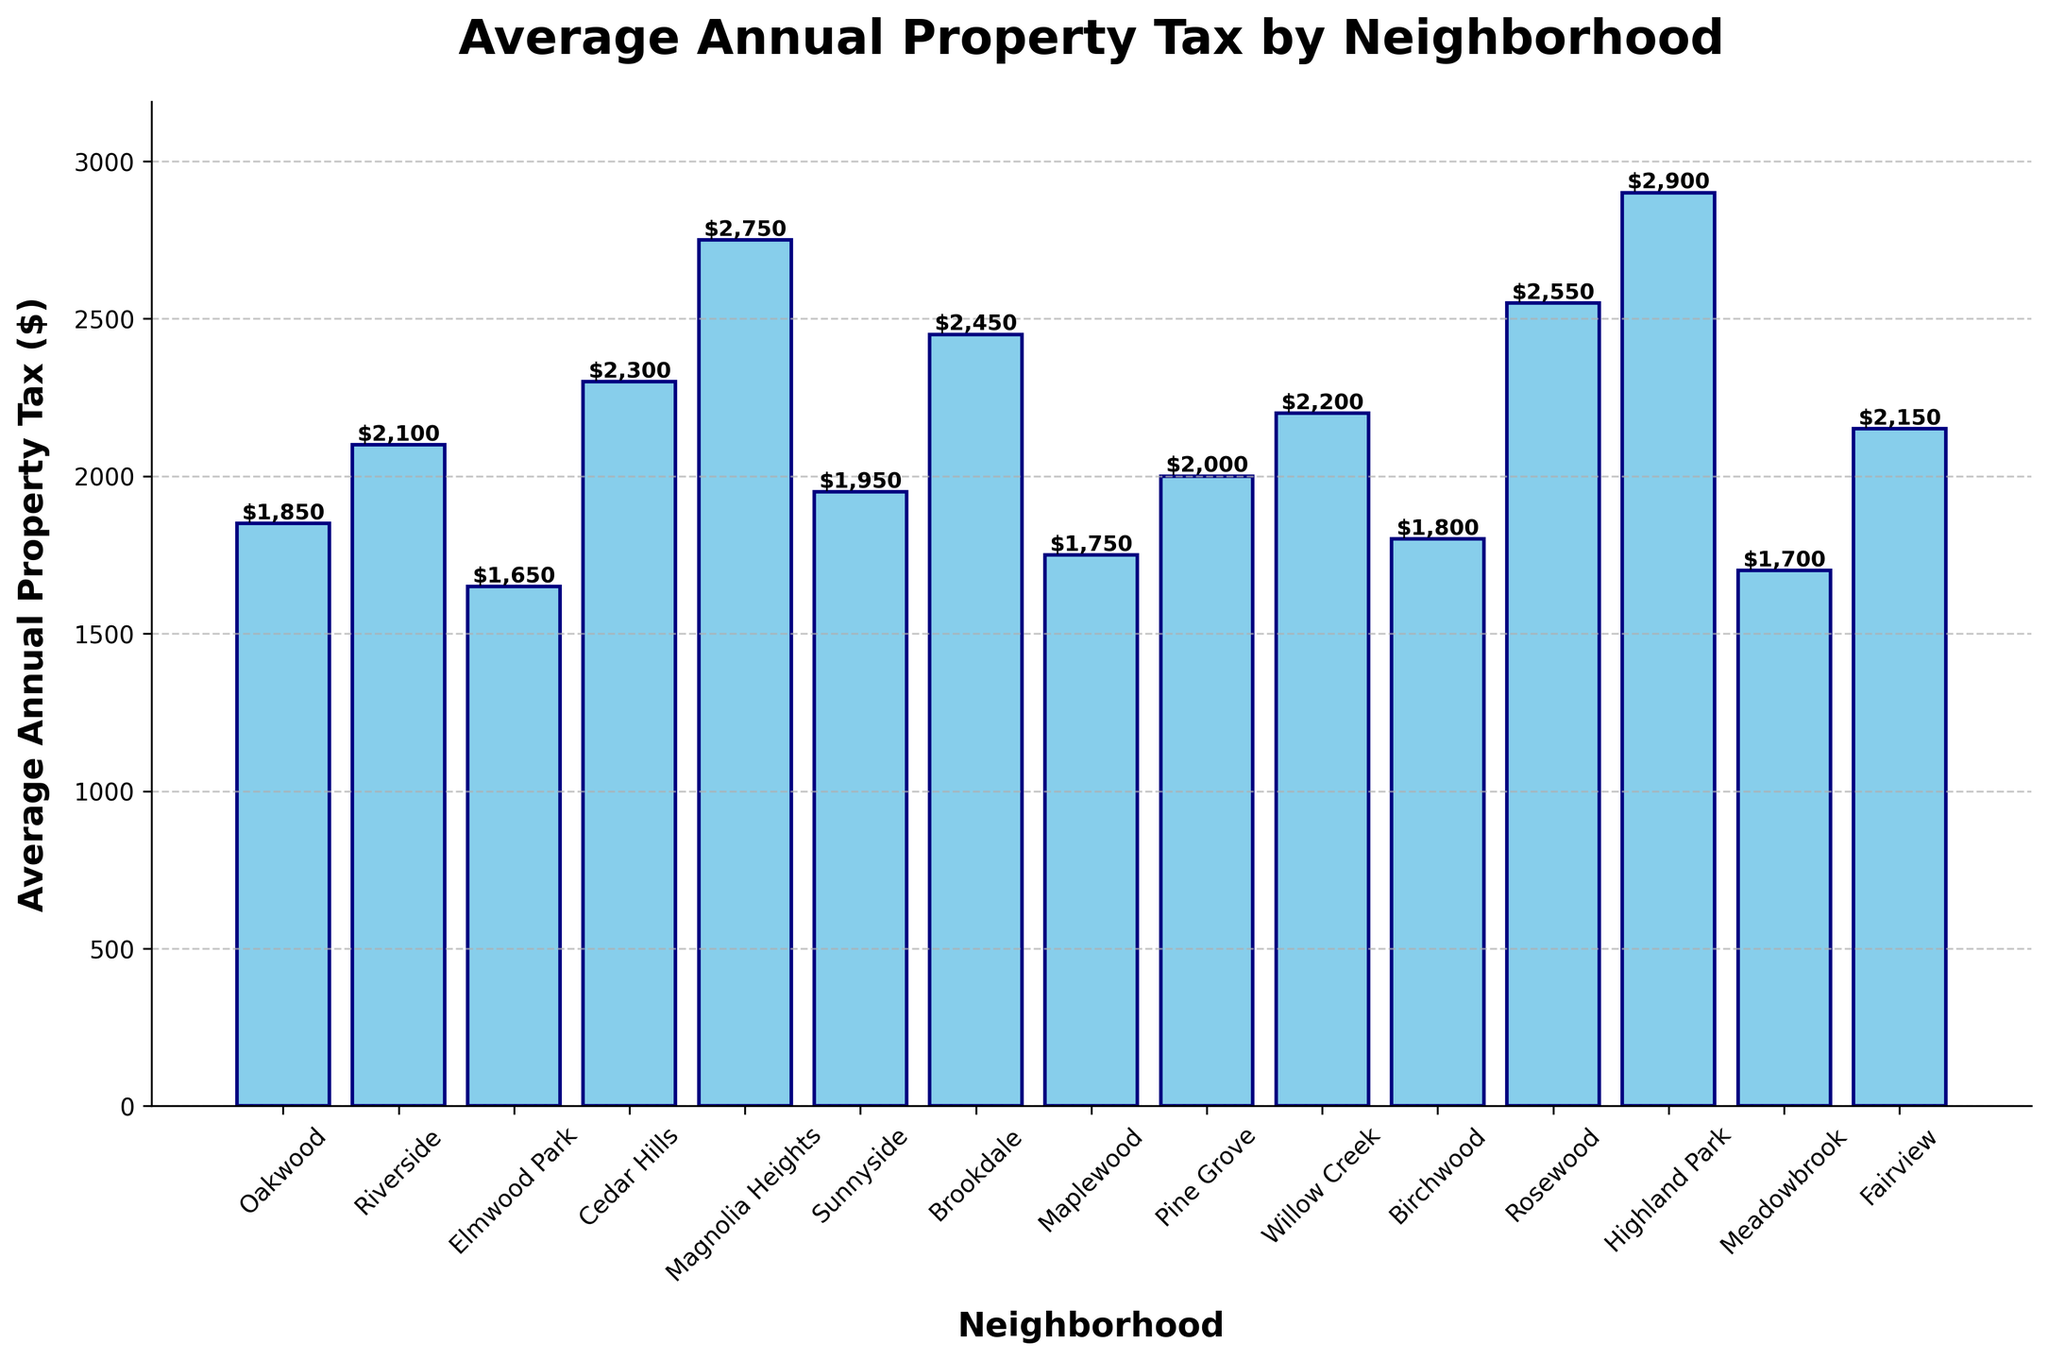Which neighborhood has the highest average annual property tax? The highest bar indicates the neighborhood with the highest tax. Magnolia Heights has the tallest bar.
Answer: Magnolia Heights Which neighborhood has the lowest average annual property tax? The shortest bar indicates the neighborhood with the lowest tax. Elmwood Park has the shortest bar.
Answer: Elmwood Park How much higher is the average annual property tax in Highland Park compared to Willow Creek? The height difference between the bars for Highland Park and Willow Creek represents this difference. Highland Park’s tax is $2900, and Willow Creek’s tax is $2200. The difference is $2900 - $2200 = $700.
Answer: $700 What is the average annual property tax for neighborhoods with a tax of over $2500? Identify the neighborhoods where the bars are above $2500 (Magnolia Heights, Rosewood, and Highland Park) and average their taxes. The sum is $2750 + $2550 + $2900 = $8200, and the average is $8200 / 3 = $2733.33.
Answer: $2733.33 How many neighborhoods have average annual property taxes between $2000 and $2500? Count the bars whose heights fall between $2000 and $2500. These neighborhoods are Riverside, Cedar Hills, Brookdale, Willow Creek, and Fairview. There are 5 bars.
Answer: 5 Which two neighborhoods have the closest average annual property taxes? Compare the height of each bar to find the smallest difference. Birchwood ($1800) and Oakwood ($1850) have the closest tax values with a difference of $50.
Answer: Birchwood and Oakwood Arrange the neighborhoods with property taxes under $2000 in descending order. Identify the neighborhoods with bars under $2000 and list them from highest to lowest. Oakwood ($1850), Birchwood ($1800), Maplewood ($1750), Meadowbrook ($1700), Elmwood Park ($1650).
Answer: Oakwood, Birchwood, Maplewood, Meadowbrook, Elmwood Park What is the difference in average annual property tax between the highest and the lowest taxed neighborhoods? Subtract the lowest tax (Elmwood Park, $1650) from the highest (Highland Park, $2900). The difference is $2900 - $1650 = $1250.
Answer: $1250 What is the combined total of the average annual property taxes for Oakwood and Cedar Hills? Add the taxes for Oakwood ($1850) and Cedar Hills ($2300). The total is $1850 + $2300 = $4150.
Answer: $4150 Which neighborhood has a property tax closest to the median value? First, list all values and find the median: [1650, 1700, 1750, 1800, 1850, 1950, 2000, 2100, 2150, 2200, 2300, 2450, 2550, 2750, 2900]. The median is the 8th value, which is $2000. Pine Grove has this value.
Answer: Pine Grove 